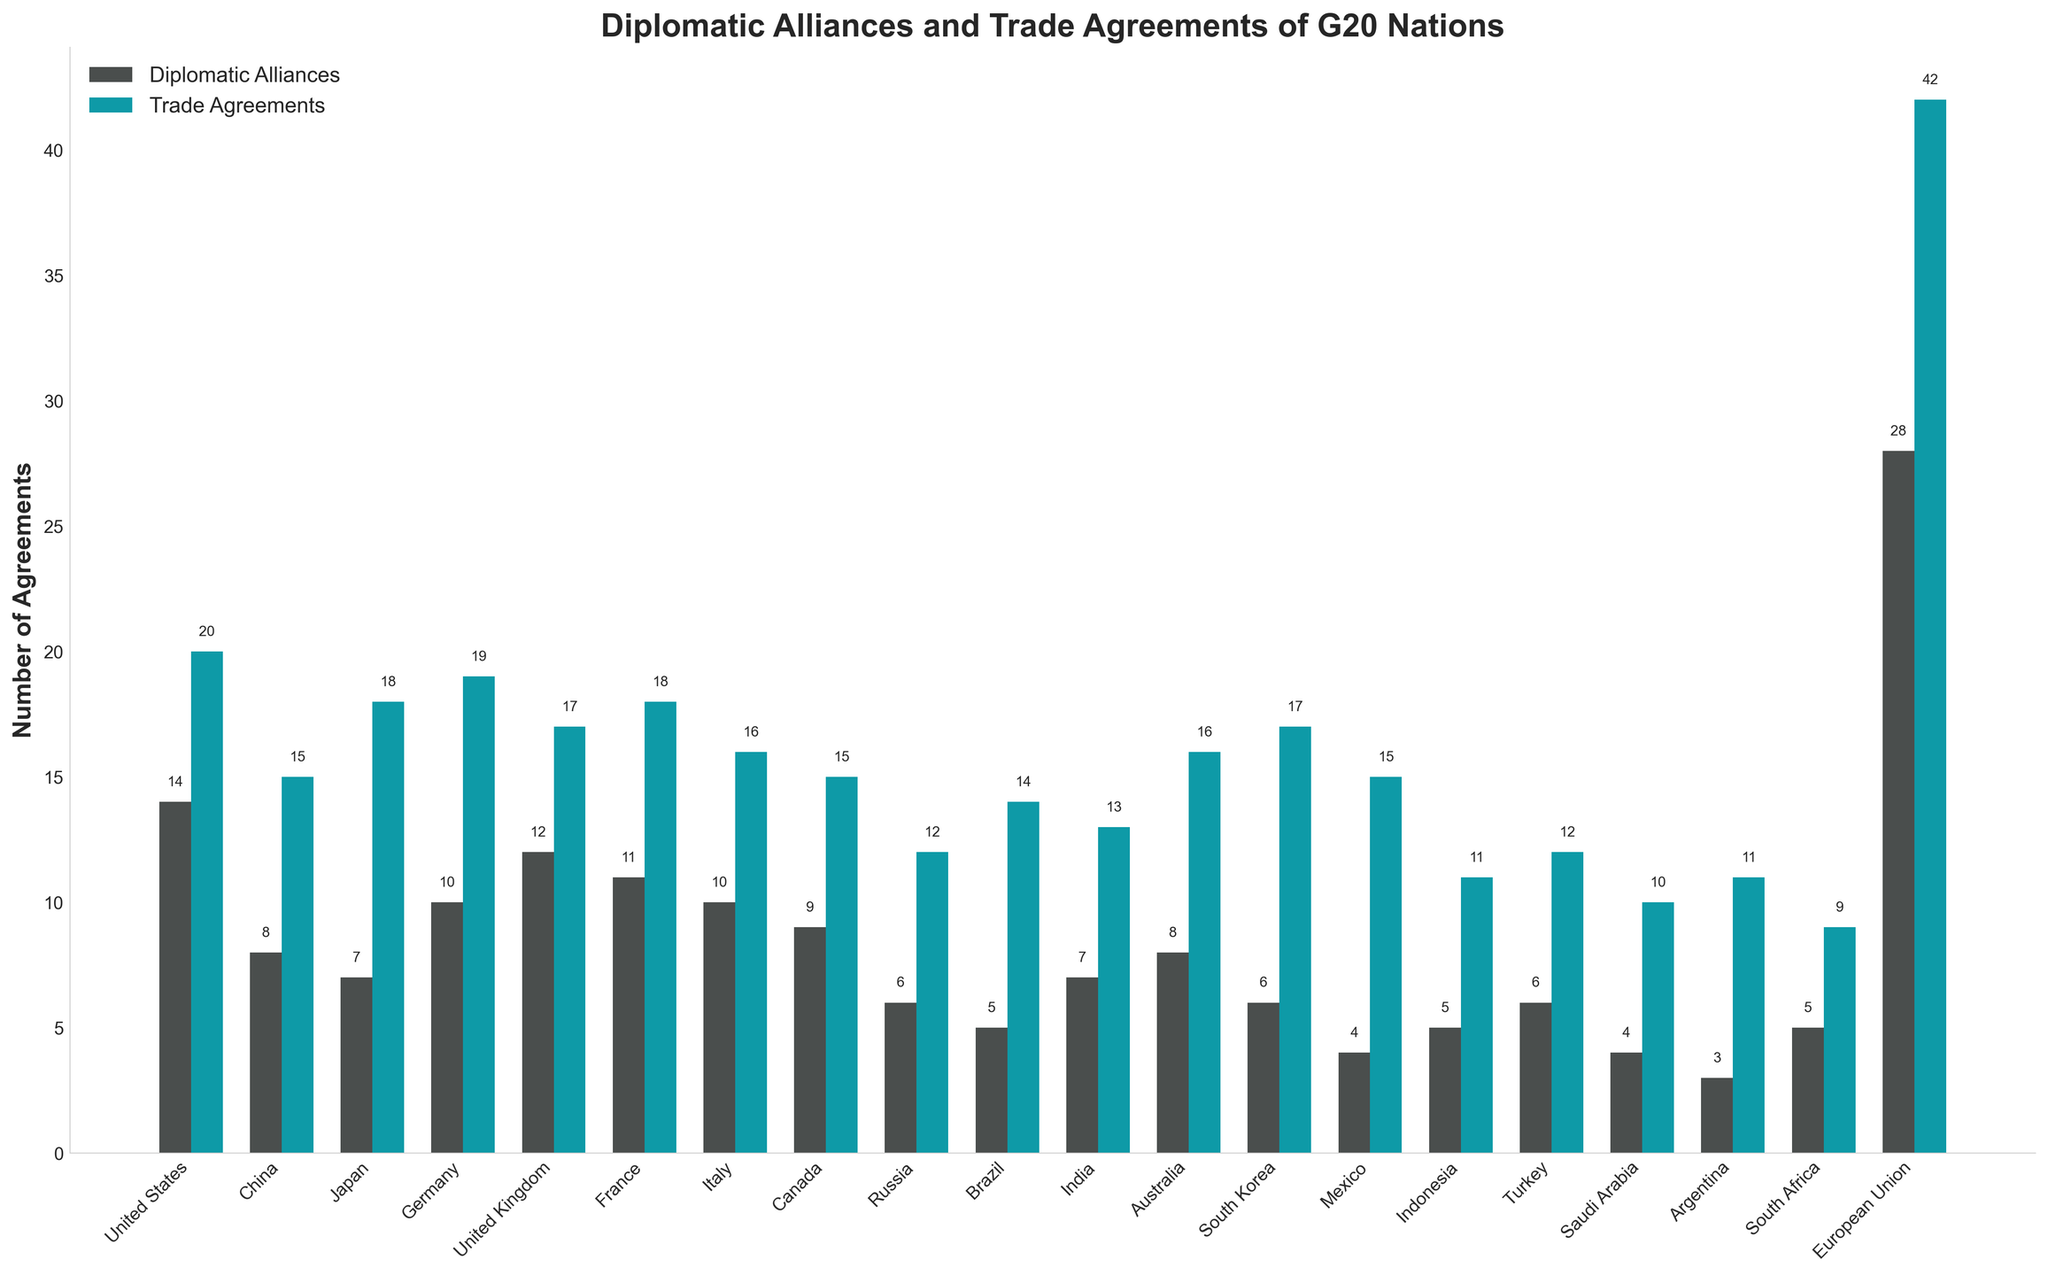What's the country with the highest number of diplomatic alliances? Look at the height of the bars corresponding to diplomatic alliances for each country. The European Union has the tallest bar in this category.
Answer: European Union Which country has more trade agreements, Canada or Mexico? Compare the heights of the bars for trade agreements for both Canada and Mexico. Canada's bar is taller than Mexico's.
Answer: Canada What is the total number of diplomatic alliances for Germany, France, and Italy combined? Sum the number of diplomatic alliances for Germany (10), France (11), and Italy (10). 10 + 11 + 10 = 31
Answer: 31 Which country has fewer trade agreements than Saudi Arabia but more diplomatic alliances than Argentina? Identify Saudi Arabia's trade agreements (10) and Argentina’s diplomatic alliances (3). South Africa has 9 trade agreements (less than Saudi Arabia) and 5 diplomatic alliances (more than Argentina).
Answer: South Africa What's the difference between the number of trade agreements of the United States and China? The United States has 20 trade agreements, and China has 15. Calculate the difference: 20 - 15 = 5
Answer: 5 Which country has an equal number of diplomatic alliances and trade agreements? Compare the values of diplomatic alliances and trade agreements for each country. There is no country with equal numbers in both categories.
Answer: None What are the combined trade agreements of Japan and South Korea? Sum the trade agreements for Japan (18) and South Korea (17). 18 + 17 = 35
Answer: 35 How many more diplomatic alliances does the European Union have compared to Russia? The European Union has 28 diplomatic alliances, and Russia has 6. Subtract Russia's alliances from the EU's: 28 - 6 = 22
Answer: 22 Which country has the lowest number of diplomatic alliances? Look at the heights of the bars and find the smallest one in the diplomatic alliances category. Argentina has the lowest with 3.
Answer: Argentina 